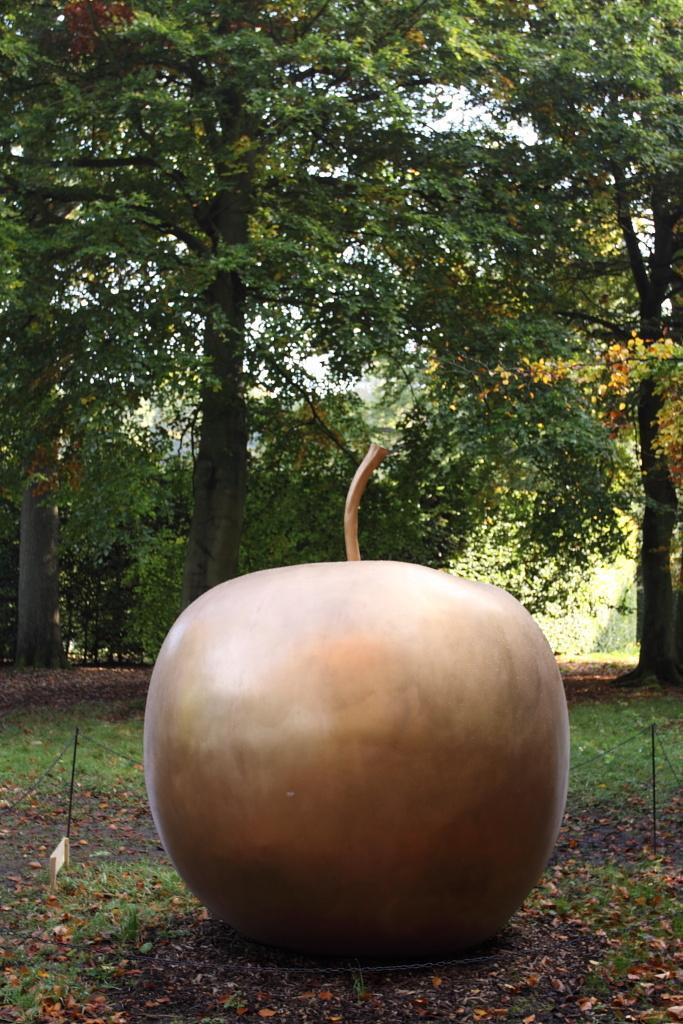Describe this image in one or two sentences. In this image I can see some object in brown color. In the background I can see few trees in green color and the sky is in white color. 